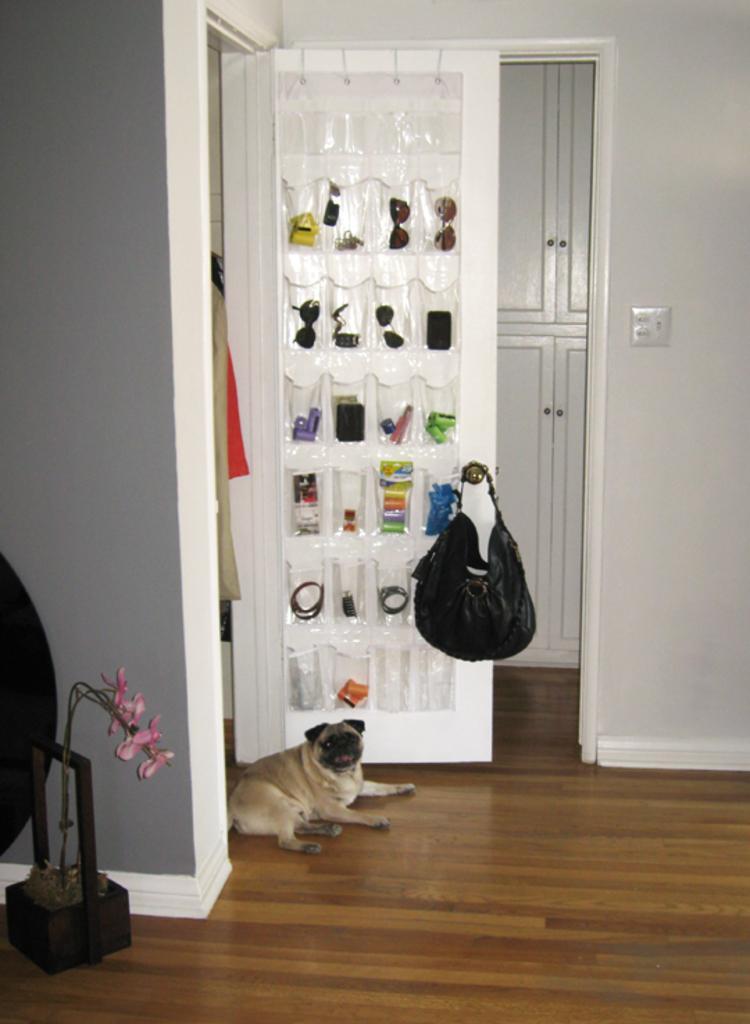Could you give a brief overview of what you see in this image? Its inside a home, there is a door with covers , it had many glasses and cosmetics in it and a bag hanging to it. And in front of door there is a puppy laying, over left side of image there is flower which was bent. 